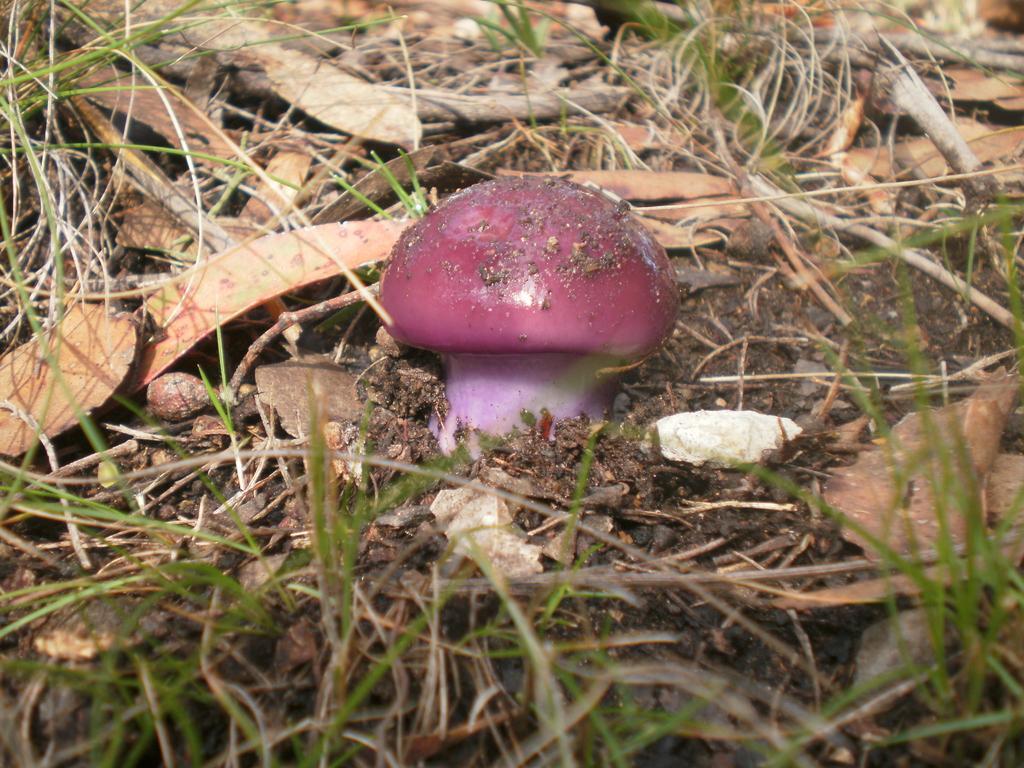Can you describe this image briefly? In the picture I can see the mushroom and broken wooden blocks. I can see the green grass. I can see the stones on the soil. 